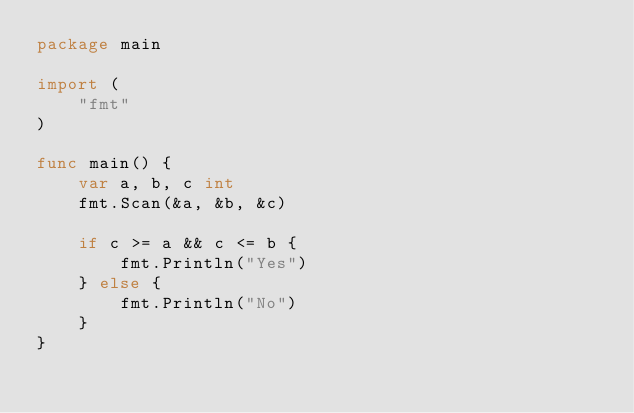<code> <loc_0><loc_0><loc_500><loc_500><_Go_>package main

import (
	"fmt"
)

func main() {
	var a, b, c int
	fmt.Scan(&a, &b, &c)

	if c >= a && c <= b {
		fmt.Println("Yes")
	} else {
		fmt.Println("No")
	}
}
</code> 